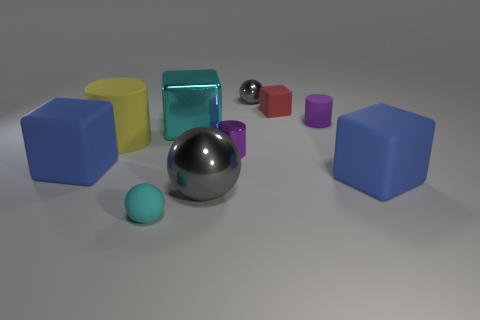What is the material of the other sphere that is the same size as the rubber sphere?
Keep it short and to the point. Metal. Are there more small cyan matte balls right of the tiny cyan matte sphere than small purple cylinders to the left of the tiny gray thing?
Keep it short and to the point. No. What is the material of the cube that is behind the yellow matte thing and to the left of the big ball?
Give a very brief answer. Metal. Does the purple matte thing have the same shape as the yellow object?
Your answer should be compact. Yes. There is a tiny cyan ball; what number of tiny rubber objects are in front of it?
Ensure brevity in your answer.  0. There is a blue rubber block on the left side of the purple matte object; does it have the same size as the tiny red rubber thing?
Your response must be concise. No. There is another tiny object that is the same shape as the tiny gray thing; what color is it?
Ensure brevity in your answer.  Cyan. What is the shape of the large object that is to the right of the red rubber thing?
Ensure brevity in your answer.  Cube. How many large cyan objects are the same shape as the small gray thing?
Your response must be concise. 0. There is a small shiny thing behind the tiny red block; is its color the same as the metallic sphere that is to the left of the shiny cylinder?
Keep it short and to the point. Yes. 